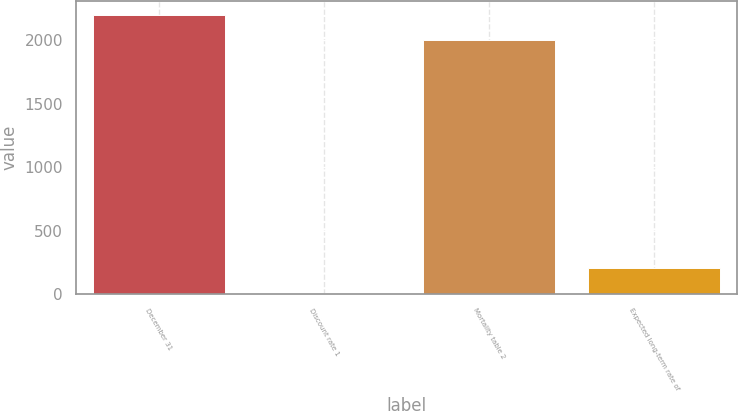<chart> <loc_0><loc_0><loc_500><loc_500><bar_chart><fcel>December 31<fcel>Discount rate 1<fcel>Mortality table 2<fcel>Expected long-term rate of<nl><fcel>2200.61<fcel>4.9<fcel>2000<fcel>205.51<nl></chart> 